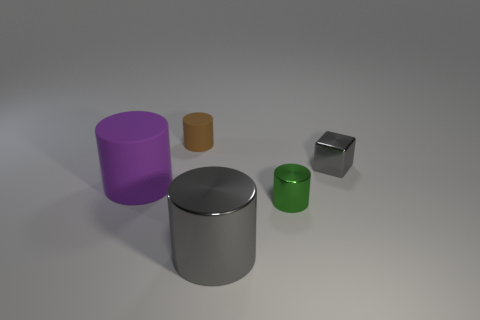What shape is the small object that is made of the same material as the small cube?
Keep it short and to the point. Cylinder. Are there fewer metallic cylinders to the left of the big gray cylinder than big objects?
Your response must be concise. Yes. The rubber cylinder on the right side of the purple cylinder is what color?
Offer a terse response. Brown. There is a cylinder that is the same color as the tiny metal block; what material is it?
Ensure brevity in your answer.  Metal. Are there any green metal objects of the same shape as the brown matte object?
Your answer should be compact. Yes. What number of small brown rubber objects have the same shape as the large purple thing?
Offer a very short reply. 1. Is the color of the large metallic thing the same as the large matte thing?
Provide a short and direct response. No. Are there fewer yellow shiny cubes than gray blocks?
Give a very brief answer. Yes. What is the material of the big thing in front of the small green shiny cylinder?
Keep it short and to the point. Metal. What is the material of the thing that is the same size as the purple cylinder?
Provide a short and direct response. Metal. 